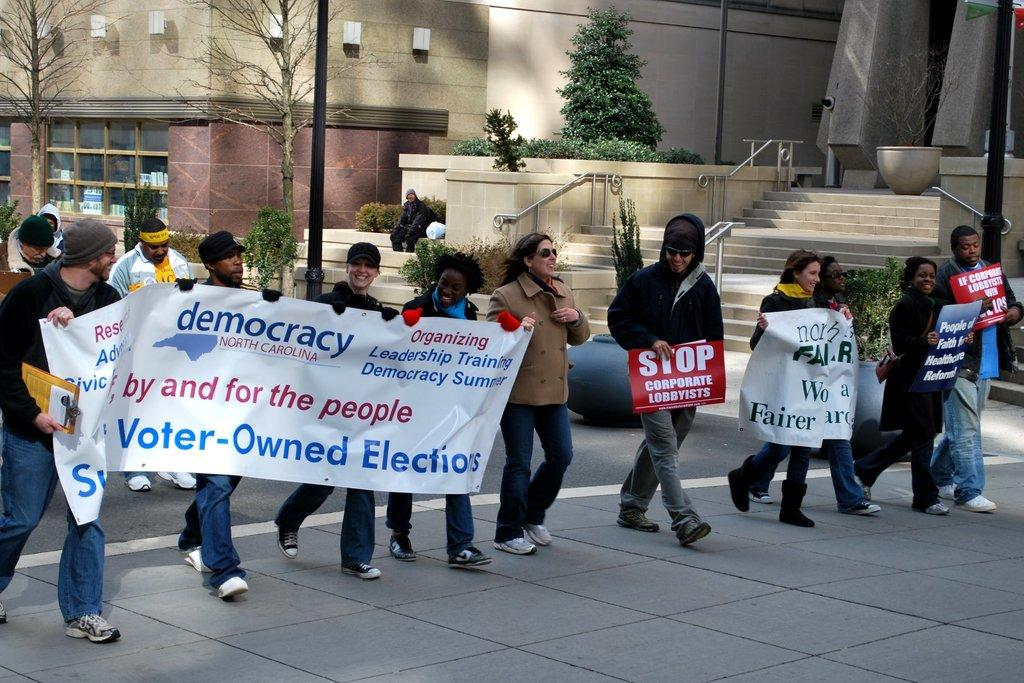What are the people in the image holding? The people in the image are holding banners. What type of vegetation can be seen in the image? There are plants and trees visible in the image. What architectural feature is present in the image? There are steps in the image. What other objects can be seen in the image? There are poles and pots in the image. How many people are visible in the image? There is at least one person in the image. What can be seen in the background of the image? There are buildings in the background of the image. Can you see the sea in the image? No, there is no sea visible in the image. Is there a stage present in the image? No, there is no stage visible in the image. 